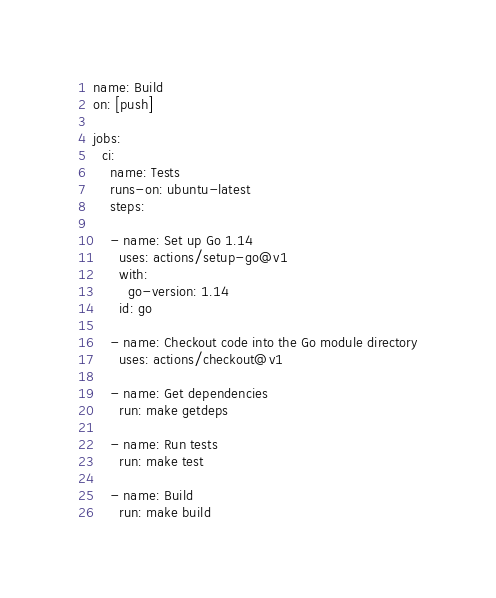<code> <loc_0><loc_0><loc_500><loc_500><_YAML_>name: Build
on: [push]

jobs:
  ci:
    name: Tests
    runs-on: ubuntu-latest
    steps:

    - name: Set up Go 1.14
      uses: actions/setup-go@v1
      with:
        go-version: 1.14
      id: go

    - name: Checkout code into the Go module directory
      uses: actions/checkout@v1

    - name: Get dependencies
      run: make getdeps

    - name: Run tests
      run: make test

    - name: Build
      run: make build</code> 